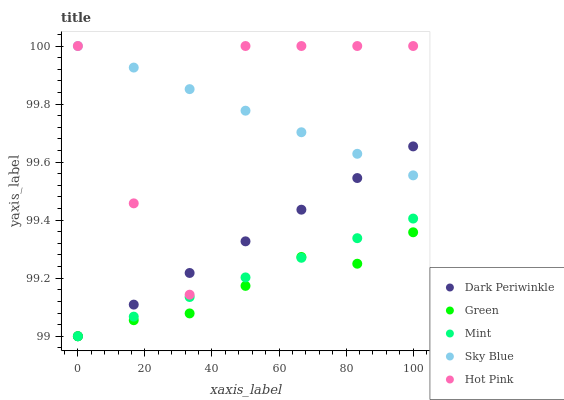Does Green have the minimum area under the curve?
Answer yes or no. Yes. Does Sky Blue have the maximum area under the curve?
Answer yes or no. Yes. Does Hot Pink have the minimum area under the curve?
Answer yes or no. No. Does Hot Pink have the maximum area under the curve?
Answer yes or no. No. Is Mint the smoothest?
Answer yes or no. Yes. Is Hot Pink the roughest?
Answer yes or no. Yes. Is Green the smoothest?
Answer yes or no. No. Is Green the roughest?
Answer yes or no. No. Does Mint have the lowest value?
Answer yes or no. Yes. Does Hot Pink have the lowest value?
Answer yes or no. No. Does Sky Blue have the highest value?
Answer yes or no. Yes. Does Green have the highest value?
Answer yes or no. No. Is Green less than Hot Pink?
Answer yes or no. Yes. Is Sky Blue greater than Green?
Answer yes or no. Yes. Does Mint intersect Dark Periwinkle?
Answer yes or no. Yes. Is Mint less than Dark Periwinkle?
Answer yes or no. No. Is Mint greater than Dark Periwinkle?
Answer yes or no. No. Does Green intersect Hot Pink?
Answer yes or no. No. 